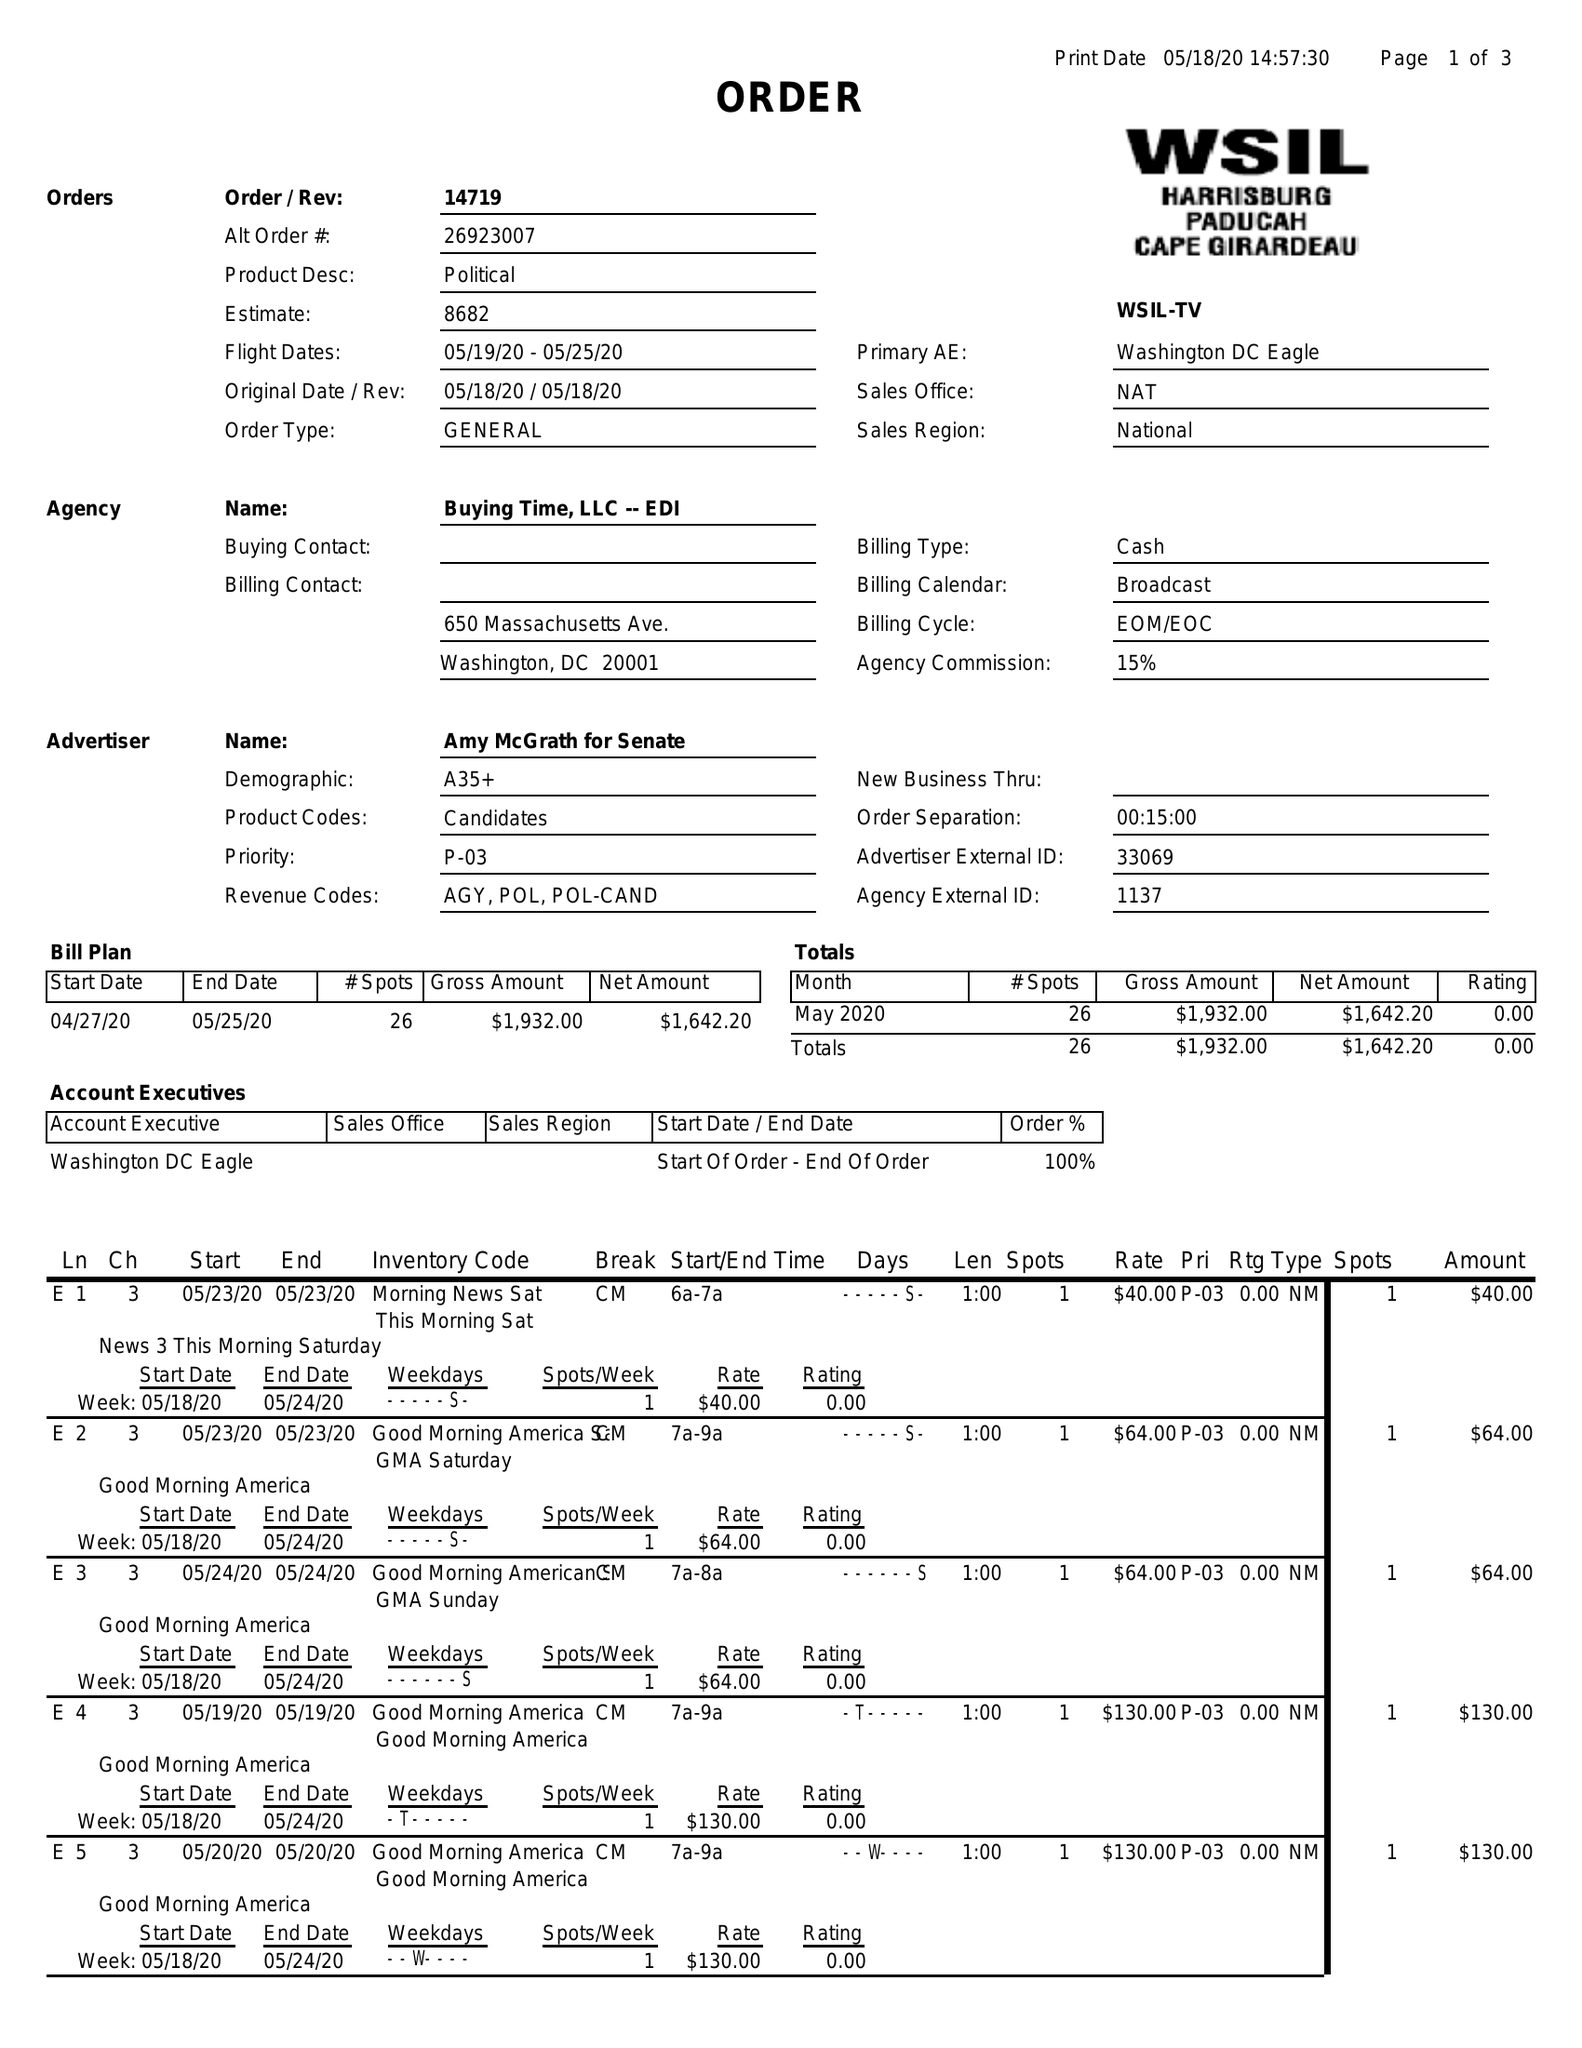What is the value for the contract_num?
Answer the question using a single word or phrase. 14719 